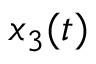Convert formula to latex. <formula><loc_0><loc_0><loc_500><loc_500>x _ { 3 } ( t )</formula> 